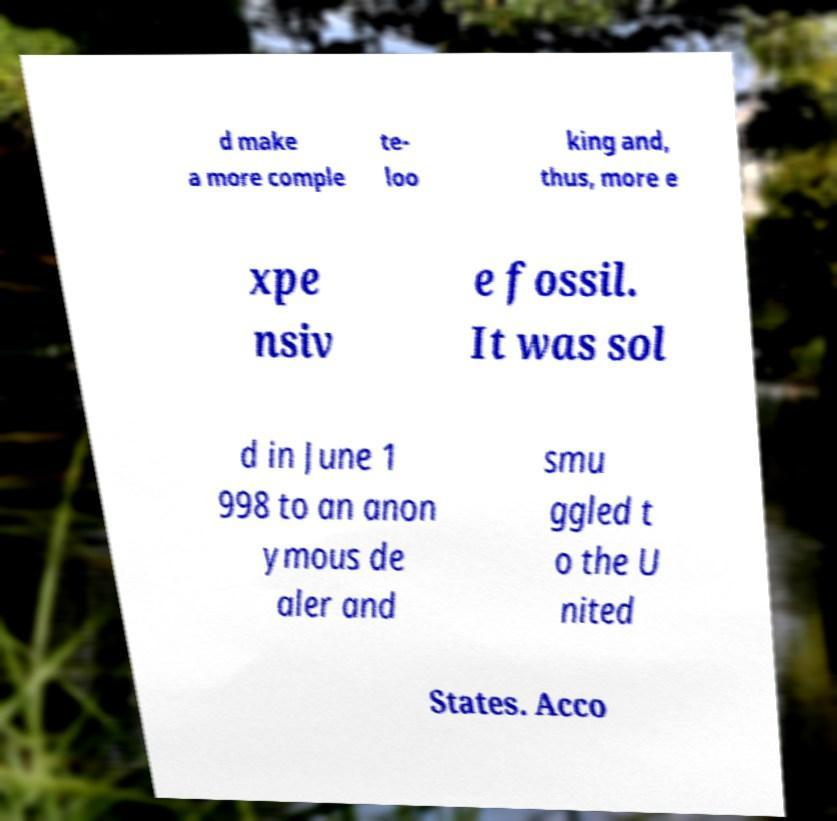I need the written content from this picture converted into text. Can you do that? d make a more comple te- loo king and, thus, more e xpe nsiv e fossil. It was sol d in June 1 998 to an anon ymous de aler and smu ggled t o the U nited States. Acco 